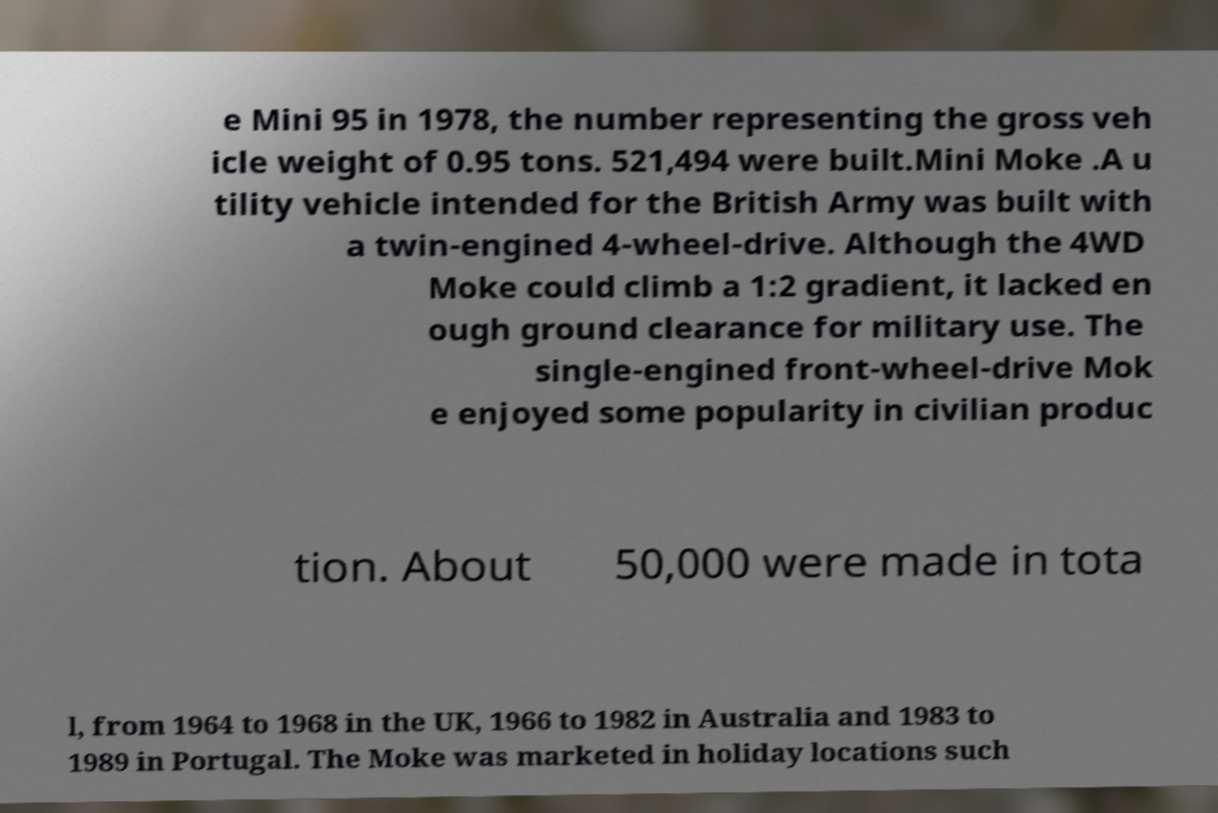There's text embedded in this image that I need extracted. Can you transcribe it verbatim? e Mini 95 in 1978, the number representing the gross veh icle weight of 0.95 tons. 521,494 were built.Mini Moke .A u tility vehicle intended for the British Army was built with a twin-engined 4-wheel-drive. Although the 4WD Moke could climb a 1:2 gradient, it lacked en ough ground clearance for military use. The single-engined front-wheel-drive Mok e enjoyed some popularity in civilian produc tion. About 50,000 were made in tota l, from 1964 to 1968 in the UK, 1966 to 1982 in Australia and 1983 to 1989 in Portugal. The Moke was marketed in holiday locations such 